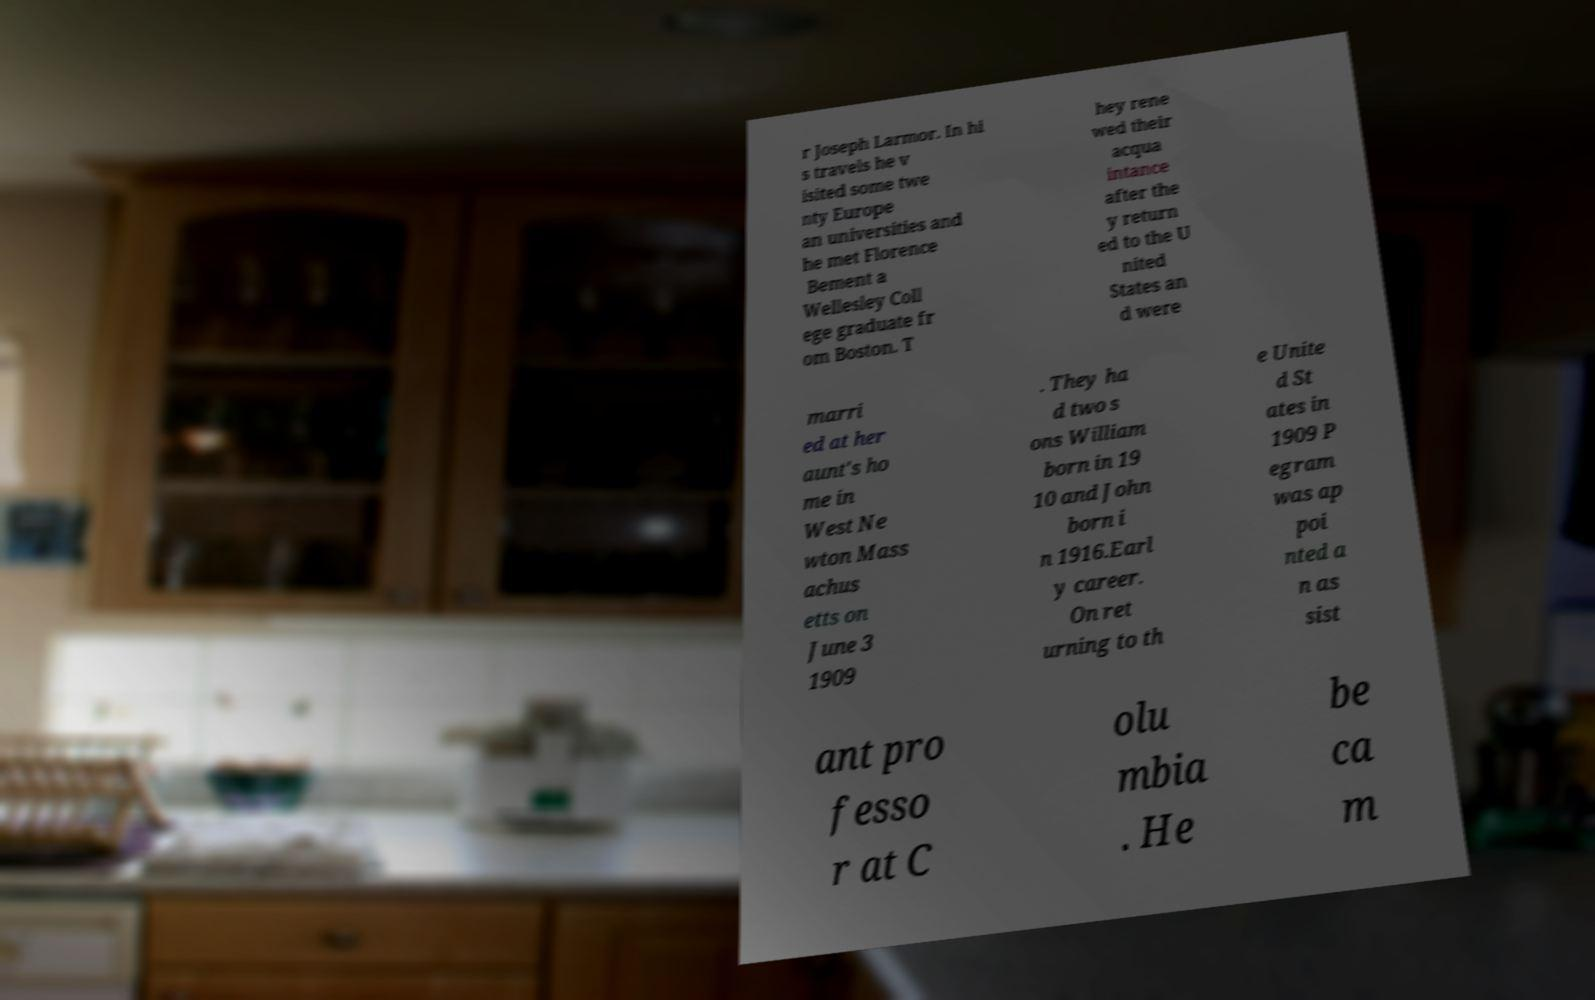Please identify and transcribe the text found in this image. r Joseph Larmor. In hi s travels he v isited some twe nty Europe an universities and he met Florence Bement a Wellesley Coll ege graduate fr om Boston. T hey rene wed their acqua intance after the y return ed to the U nited States an d were marri ed at her aunt's ho me in West Ne wton Mass achus etts on June 3 1909 . They ha d two s ons William born in 19 10 and John born i n 1916.Earl y career. On ret urning to th e Unite d St ates in 1909 P egram was ap poi nted a n as sist ant pro fesso r at C olu mbia . He be ca m 